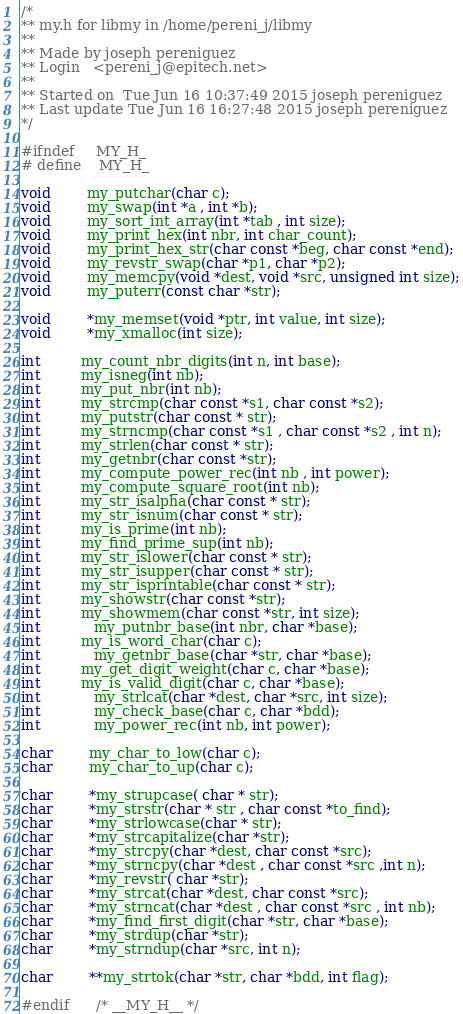Convert code to text. <code><loc_0><loc_0><loc_500><loc_500><_C_>/*
** my.h for libmy in /home/pereni_j/libmy
**
** Made by joseph pereniguez
** Login   <pereni_j@epitech.net>
**
** Started on  Tue Jun 16 10:37:49 2015 joseph pereniguez
** Last update Tue Jun 16 16:27:48 2015 joseph pereniguez
*/

#ifndef     MY_H_
# define    MY_H_

void        my_putchar(char c);
void        my_swap(int *a , int *b);
void        my_sort_int_array(int *tab , int size);
void        my_print_hex(int nbr, int char_count);
void        my_print_hex_str(char const *beg, char const *end);
void        my_revstr_swap(char *p1, char *p2);
void	    my_memcpy(void *dest, void *src, unsigned int size);
void		my_puterr(const char *str);

void        *my_memset(void *ptr, int value, int size);
void		*my_xmalloc(int size);

int         my_count_nbr_digits(int n, int base);
int         my_isneg(int nb);
int         my_put_nbr(int nb);
int         my_strcmp(char const *s1, char const *s2);
int         my_putstr(char const * str);
int         my_strncmp(char const *s1 , char const *s2 , int n);
int         my_strlen(char const * str);
int         my_getnbr(char const *str);
int         my_compute_power_rec(int nb , int power);
int         my_compute_square_root(int nb);
int         my_str_isalpha(char const * str);
int         my_str_isnum(char const * str);
int         my_is_prime(int nb);
int         my_find_prime_sup(int nb);
int         my_str_islower(char const * str);
int         my_str_isupper(char const * str);
int         my_str_isprintable(char const * str);
int         my_showstr(char const *str);
int         my_showmem(char const *str, int size);
int		    my_putnbr_base(int nbr, char *base);
int         my_is_word_char(char c);
int		    my_getnbr_base(char *str, char *base);
int         my_get_digit_weight(char c, char *base);
int         my_is_valid_digit(char c, char *base);
int		    my_strlcat(char *dest, char *src, int size);
int	        my_check_base(char c, char *bdd);
int	        my_power_rec(int nb, int power);

char        my_char_to_low(char c);
char        my_char_to_up(char c);

char        *my_strupcase( char * str);
char        *my_strstr(char * str , char const *to_find);
char        *my_strlowcase(char * str);
char        *my_strcapitalize(char *str);
char        *my_strcpy(char *dest, char const *src);
char        *my_strncpy(char *dest , char const *src ,int n);
char        *my_revstr( char *str);
char        *my_strcat(char *dest, char const *src);
char        *my_strncat(char *dest , char const *src , int nb);
char        *my_find_first_digit(char *str, char *base);
char		*my_strdup(char *str);
char		*my_strndup(char *src, int n);

char	    **my_strtok(char *str, char *bdd, int flag);

#endif      /* __MY_H__ */
</code> 